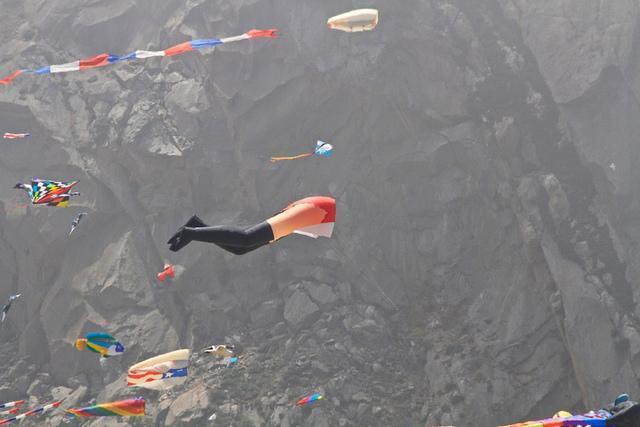How many kites are visible?
Give a very brief answer. 3. 